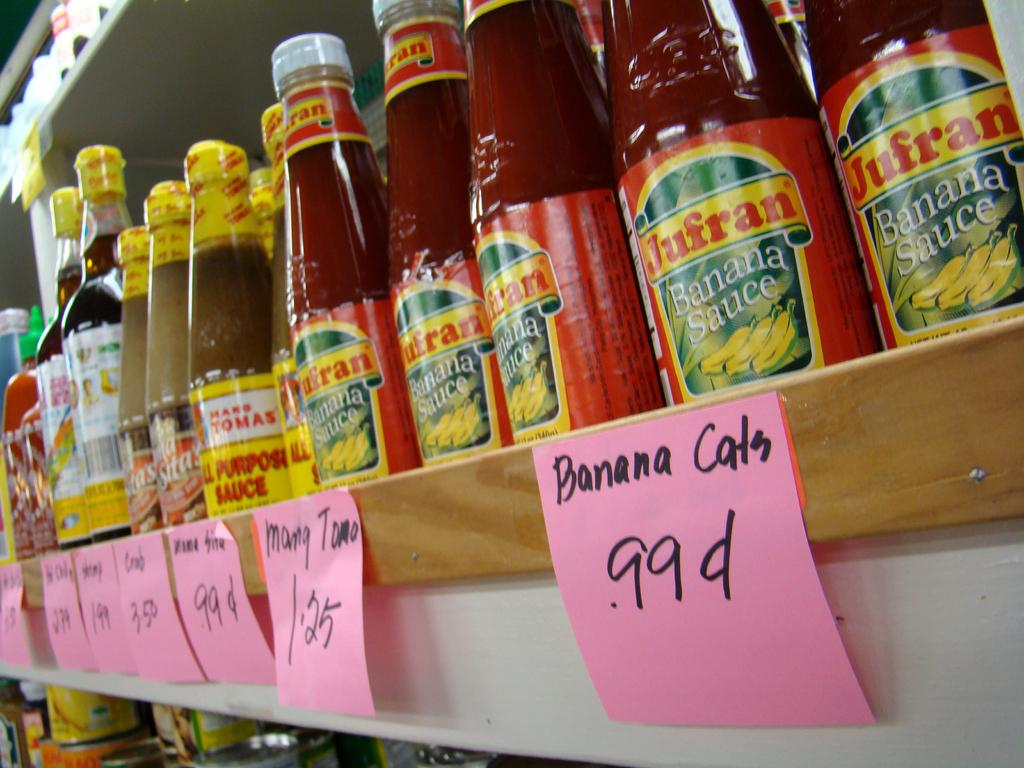<image>
Offer a succinct explanation of the picture presented. Bottles of Banana Sauce being sold for 99 cents 